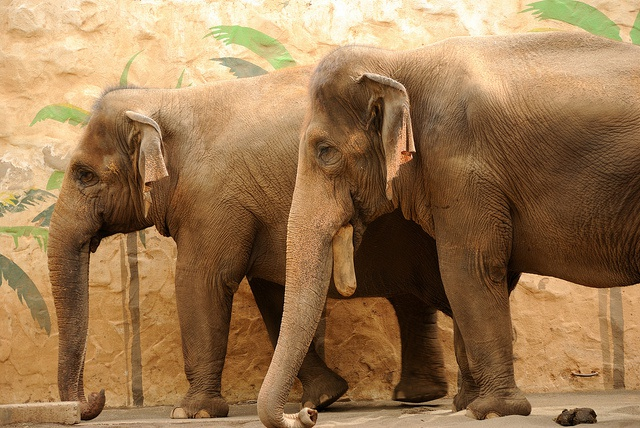Describe the objects in this image and their specific colors. I can see elephant in tan, maroon, and gray tones and elephant in tan, black, maroon, and brown tones in this image. 